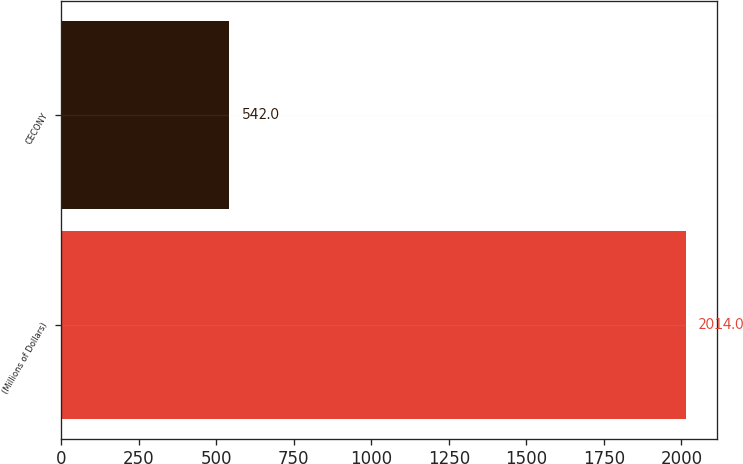Convert chart to OTSL. <chart><loc_0><loc_0><loc_500><loc_500><bar_chart><fcel>(Millions of Dollars)<fcel>CECONY<nl><fcel>2014<fcel>542<nl></chart> 